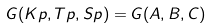Convert formula to latex. <formula><loc_0><loc_0><loc_500><loc_500>G ( K p , T p , S p ) = G ( A , B , C )</formula> 